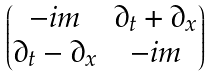Convert formula to latex. <formula><loc_0><loc_0><loc_500><loc_500>\begin{pmatrix} - i m & \partial _ { t } + \partial _ { x } \\ \partial _ { t } - \partial _ { x } & - i m \end{pmatrix}</formula> 